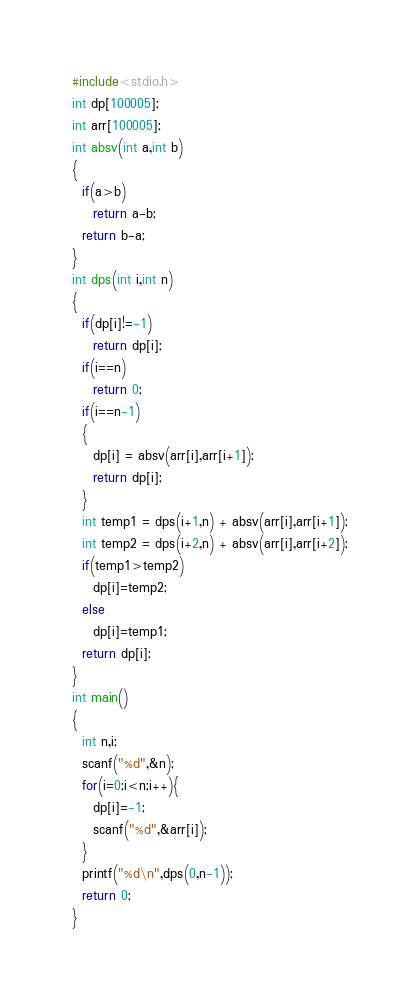<code> <loc_0><loc_0><loc_500><loc_500><_C_>#include<stdio.h>
int dp[100005];
int arr[100005];
int absv(int a,int b)
{
  if(a>b)
    return a-b;
  return b-a;
}
int dps(int i,int n)
{
  if(dp[i]!=-1)
    return dp[i];
  if(i==n)
    return 0;
  if(i==n-1)
  {
    dp[i] = absv(arr[i],arr[i+1]);
    return dp[i];
  }
  int temp1 = dps(i+1,n) + absv(arr[i],arr[i+1]);
  int temp2 = dps(i+2,n) + absv(arr[i],arr[i+2]);
  if(temp1>temp2)
    dp[i]=temp2;
  else
    dp[i]=temp1;
  return dp[i];
}
int main()
{
  int n,i;
  scanf("%d",&n);
  for(i=0;i<n;i++){
    dp[i]=-1;
    scanf("%d",&arr[i]);
  }
  printf("%d\n",dps(0,n-1));
  return 0;
}
</code> 